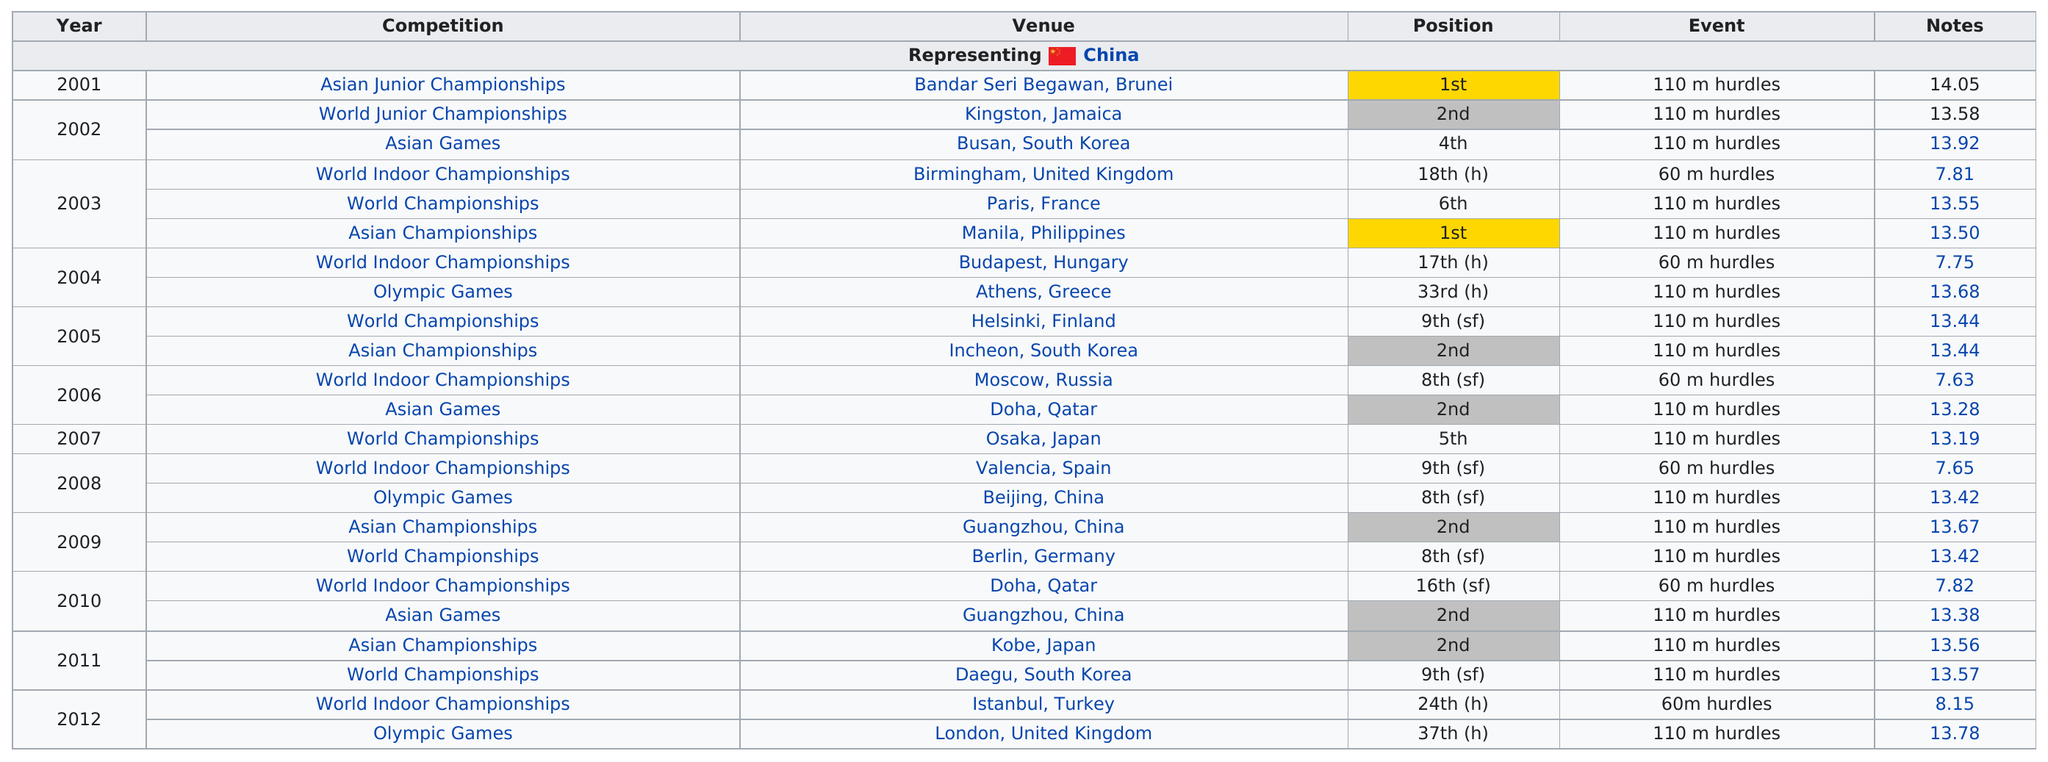Highlight a few significant elements in this photo. Dong Peng Shi competed in the Asian Junior Championships before the World Junior Championships. Liu Xiang and Dong Peng Shi competed in at least two competitions for 10 years. China finished in 5th place or better in 10 competitions. Besides their first-place finish at the Asian Junior Championships, they have also achieved first place at the Asian Championships. The number of championships listed in the table is 7. 